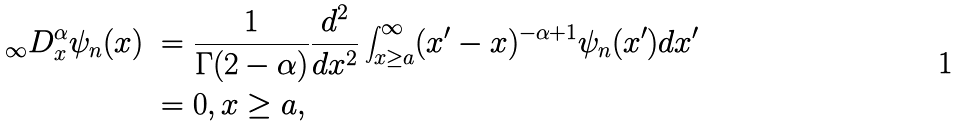Convert formula to latex. <formula><loc_0><loc_0><loc_500><loc_500>_ { \infty } D _ { x } ^ { \alpha } \psi _ { n } ( x ) \ & = \frac { 1 } { \Gamma ( 2 - \alpha ) } \frac { d ^ { 2 } } { d x ^ { 2 } } \int _ { x \geq a } ^ { \infty } ( x ^ { \prime } - x ) ^ { - \alpha + 1 } \psi _ { n } ( x ^ { \prime } ) d x ^ { \prime } \\ & = 0 , x \geq a ,</formula> 